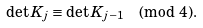<formula> <loc_0><loc_0><loc_500><loc_500>\det K _ { j } \equiv \det K _ { j - 1 } \pmod { 4 } .</formula> 